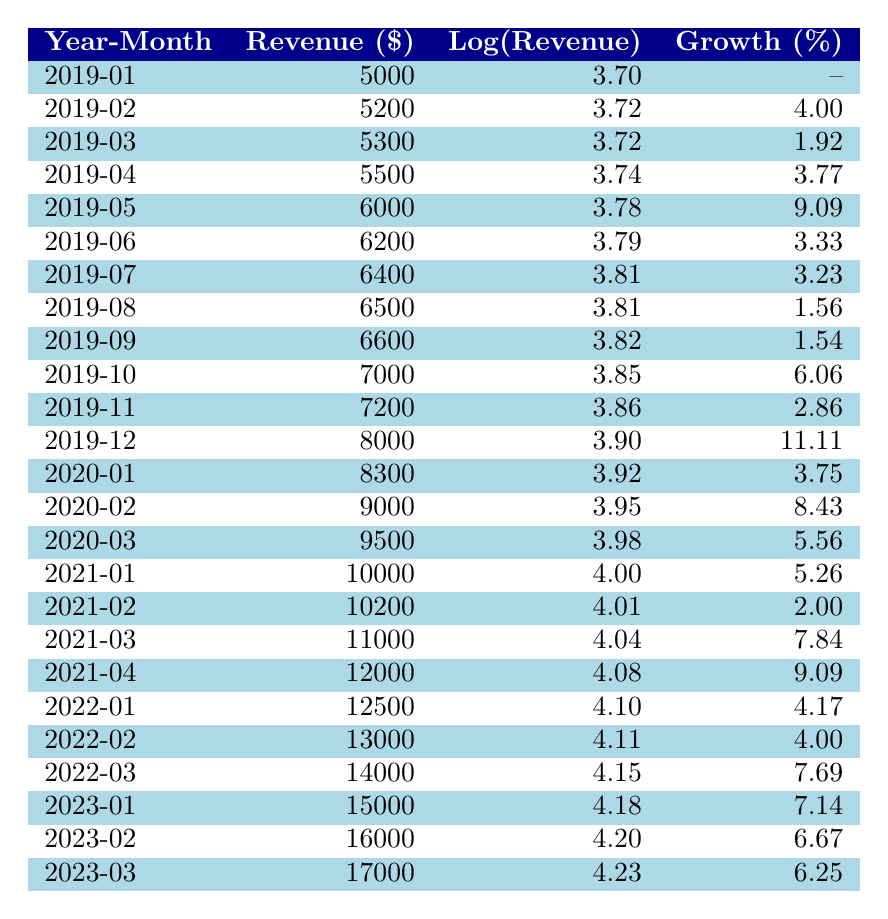What was the revenue for December 2022? According to the table, the revenue for December 2022 is not listed because there is no data for that month, only for January, February, and March. The last month for which revenue is available is March 2023.
Answer: Revenue data for December 2022 is not available What was the highest monthly gym membership revenue during the years 2019 to 2023? The highest monthly gym membership revenue listed in the table is for March 2023, which is 17,000 dollars.
Answer: 17,000 dollars What was the growth percentage from January 2022 to February 2022? The revenue in January 2022 was 12,500 dollars, and in February 2022 it was 13,000 dollars. The growth can be calculated as ((13,000 - 12,500) / 12,500) * 100 = 4%.
Answer: 4% Was there a decline in revenue between any two consecutive months in 2019? By examining the table data for 2019, all monthly revenues show an increase from January through December, confirming there was no decline in revenue.
Answer: No, there was no decline What is the average revenue from January 2021 to March 2021? The revenues for January, February, and March 2021 are 10,000, 10,200, and 11,000 dollars respectively. First, sum the revenues: 10,000 + 10,200 + 11,000 = 31,200. Then, divide this by the number of months: 31,200 / 3 = 10,400.
Answer: 10,400 dollars What was the revenue growth from January 2019 to December 2019? The revenue for January 2019 is 5,000 dollars and for December 2019 is 8,000 dollars. The growth is calculated as ((8,000 - 5,000) / 5,000) * 100 = 60%.
Answer: 60% What is the lowest monthly revenue recorded between July 2019 and March 2023? The revenues from July 2019 to March 2023 are all examined. The lowest revenue during this period is January 2019, which was 5,000 dollars.
Answer: 5,000 dollars Was the revenue in February 2020 higher than the revenue in September 2019? The revenue for February 2020 is 9,000 dollars, while for September 2019, it is 6,600 dollars. Since 9,000 is greater than 6,600, February 2020 had higher revenue.
Answer: Yes, it was higher 